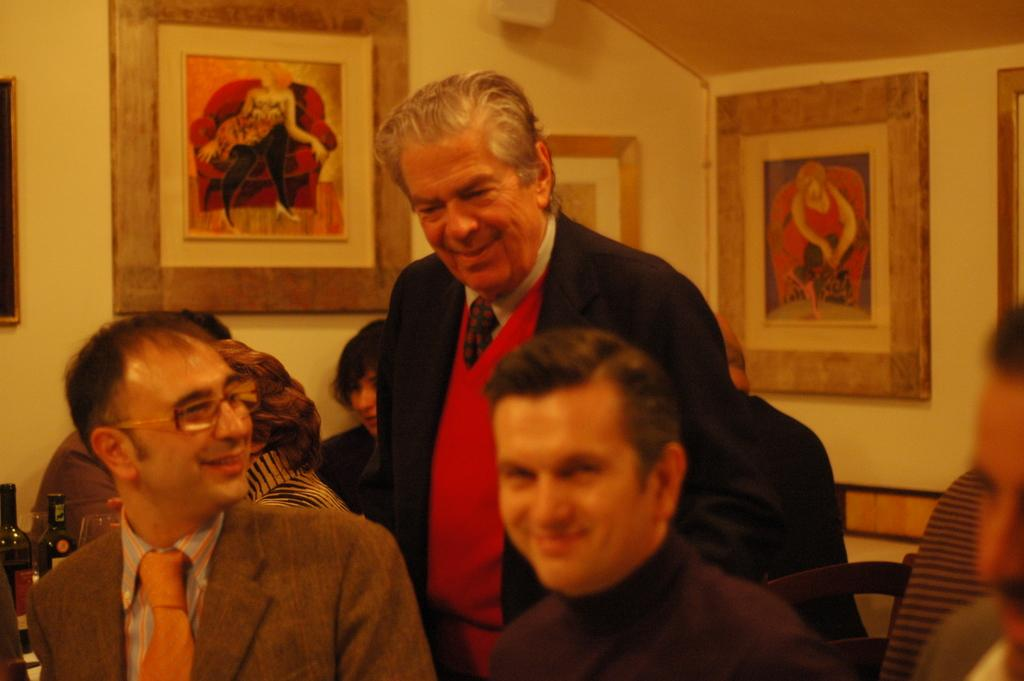How many people are sitting in the foreground of the image? There are three people sitting in the foreground of the image. What is the position of the man in relation to the sitting people? There is a man standing behind the sitting people. Can you describe the people in the background of the image? In the background, there are three people. What objects can be seen in the background of the image? There are bottles and frames on the wall visible in the background. What type of cattle can be seen grazing in the background of the image? There are no cattle present in the image; it features people sitting, standing, and in the background, as well as bottles and frames on the wall. What kind of pipe is visible in the image? There is no pipe present in the image. 